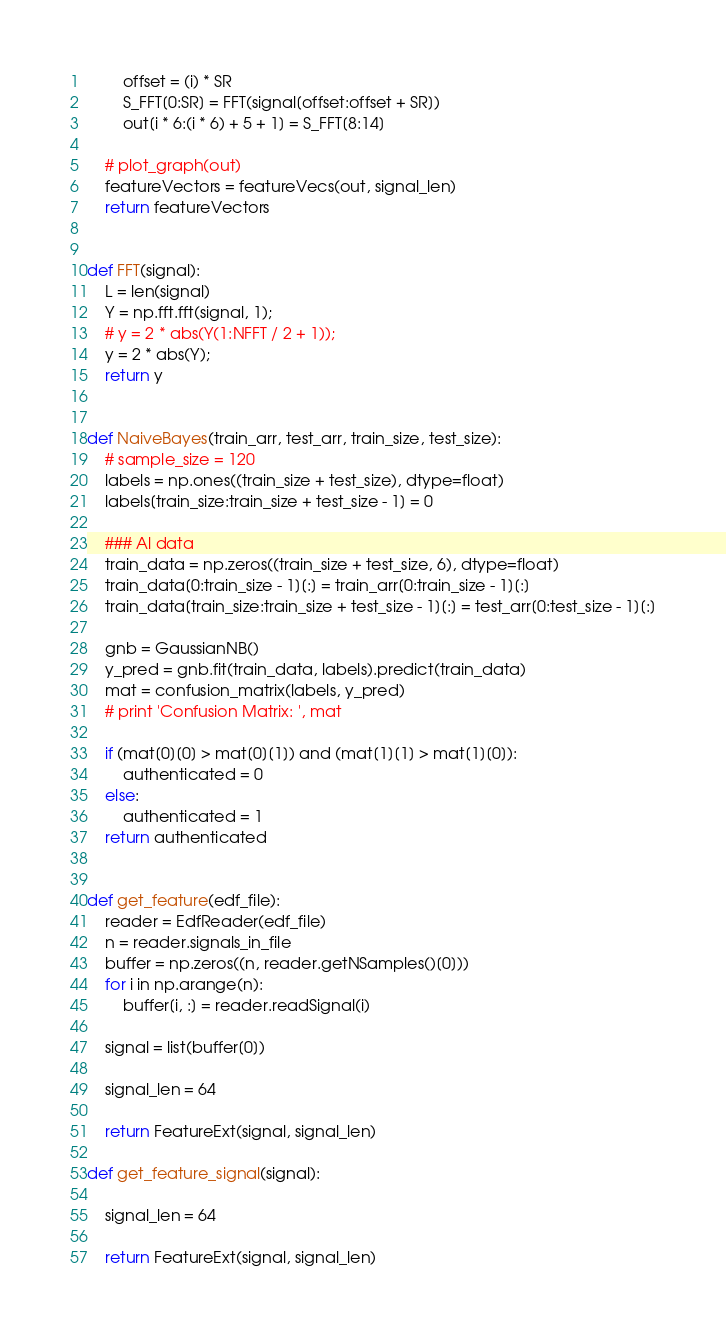<code> <loc_0><loc_0><loc_500><loc_500><_Python_>        offset = (i) * SR
        S_FFT[0:SR] = FFT(signal[offset:offset + SR])
        out[i * 6:(i * 6) + 5 + 1] = S_FFT[8:14]

    # plot_graph(out)
    featureVectors = featureVecs(out, signal_len)
    return featureVectors


def FFT(signal):
    L = len(signal)
    Y = np.fft.fft(signal, 1);
    # y = 2 * abs(Y(1:NFFT / 2 + 1));
    y = 2 * abs(Y);
    return y


def NaiveBayes(train_arr, test_arr, train_size, test_size):
    # sample_size = 120
    labels = np.ones((train_size + test_size), dtype=float)
    labels[train_size:train_size + test_size - 1] = 0

    ### Al data
    train_data = np.zeros((train_size + test_size, 6), dtype=float)
    train_data[0:train_size - 1][:] = train_arr[0:train_size - 1][:]
    train_data[train_size:train_size + test_size - 1][:] = test_arr[0:test_size - 1][:]

    gnb = GaussianNB()
    y_pred = gnb.fit(train_data, labels).predict(train_data)
    mat = confusion_matrix(labels, y_pred)
    # print 'Confusion Matrix: ', mat

    if (mat[0][0] > mat[0][1]) and (mat[1][1] > mat[1][0]):
        authenticated = 0
    else:
        authenticated = 1
    return authenticated


def get_feature(edf_file):
    reader = EdfReader(edf_file)
    n = reader.signals_in_file
    buffer = np.zeros((n, reader.getNSamples()[0]))
    for i in np.arange(n):
        buffer[i, :] = reader.readSignal(i)

    signal = list(buffer[0])

    signal_len = 64

    return FeatureExt(signal, signal_len)

def get_feature_signal(signal):

    signal_len = 64

    return FeatureExt(signal, signal_len)</code> 